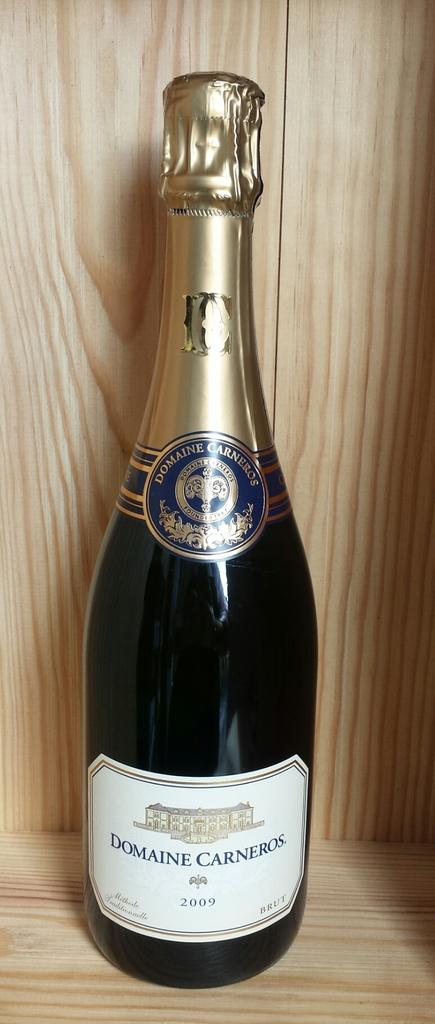Provide a one-sentence caption for the provided image. New bottle of Domaine Carneros sitting by itself. 